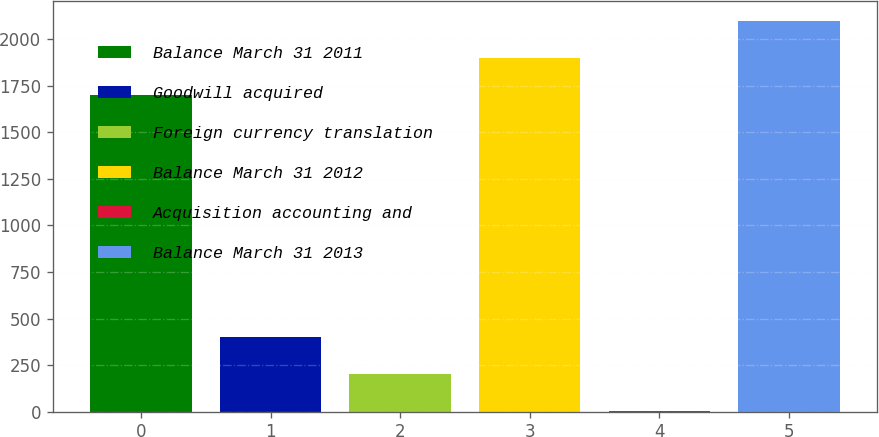Convert chart to OTSL. <chart><loc_0><loc_0><loc_500><loc_500><bar_chart><fcel>Balance March 31 2011<fcel>Goodwill acquired<fcel>Foreign currency translation<fcel>Balance March 31 2012<fcel>Acquisition accounting and<fcel>Balance March 31 2013<nl><fcel>1702<fcel>399.2<fcel>200.1<fcel>1901.1<fcel>1<fcel>2100.2<nl></chart> 